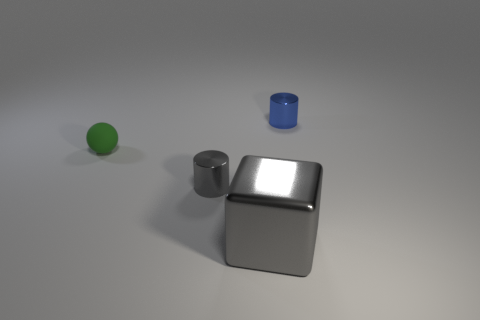Subtract all blocks. How many objects are left? 3 Subtract all brown spheres. Subtract all green cylinders. How many spheres are left? 1 Subtract all brown spheres. How many green cubes are left? 0 Subtract all gray metallic things. Subtract all big gray blocks. How many objects are left? 1 Add 2 big cubes. How many big cubes are left? 3 Add 1 big brown rubber cubes. How many big brown rubber cubes exist? 1 Add 3 tiny gray things. How many objects exist? 7 Subtract 0 cyan blocks. How many objects are left? 4 